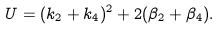<formula> <loc_0><loc_0><loc_500><loc_500>U = ( k _ { 2 } + k _ { 4 } ) ^ { 2 } + 2 ( \beta _ { 2 } + \beta _ { 4 } ) .</formula> 